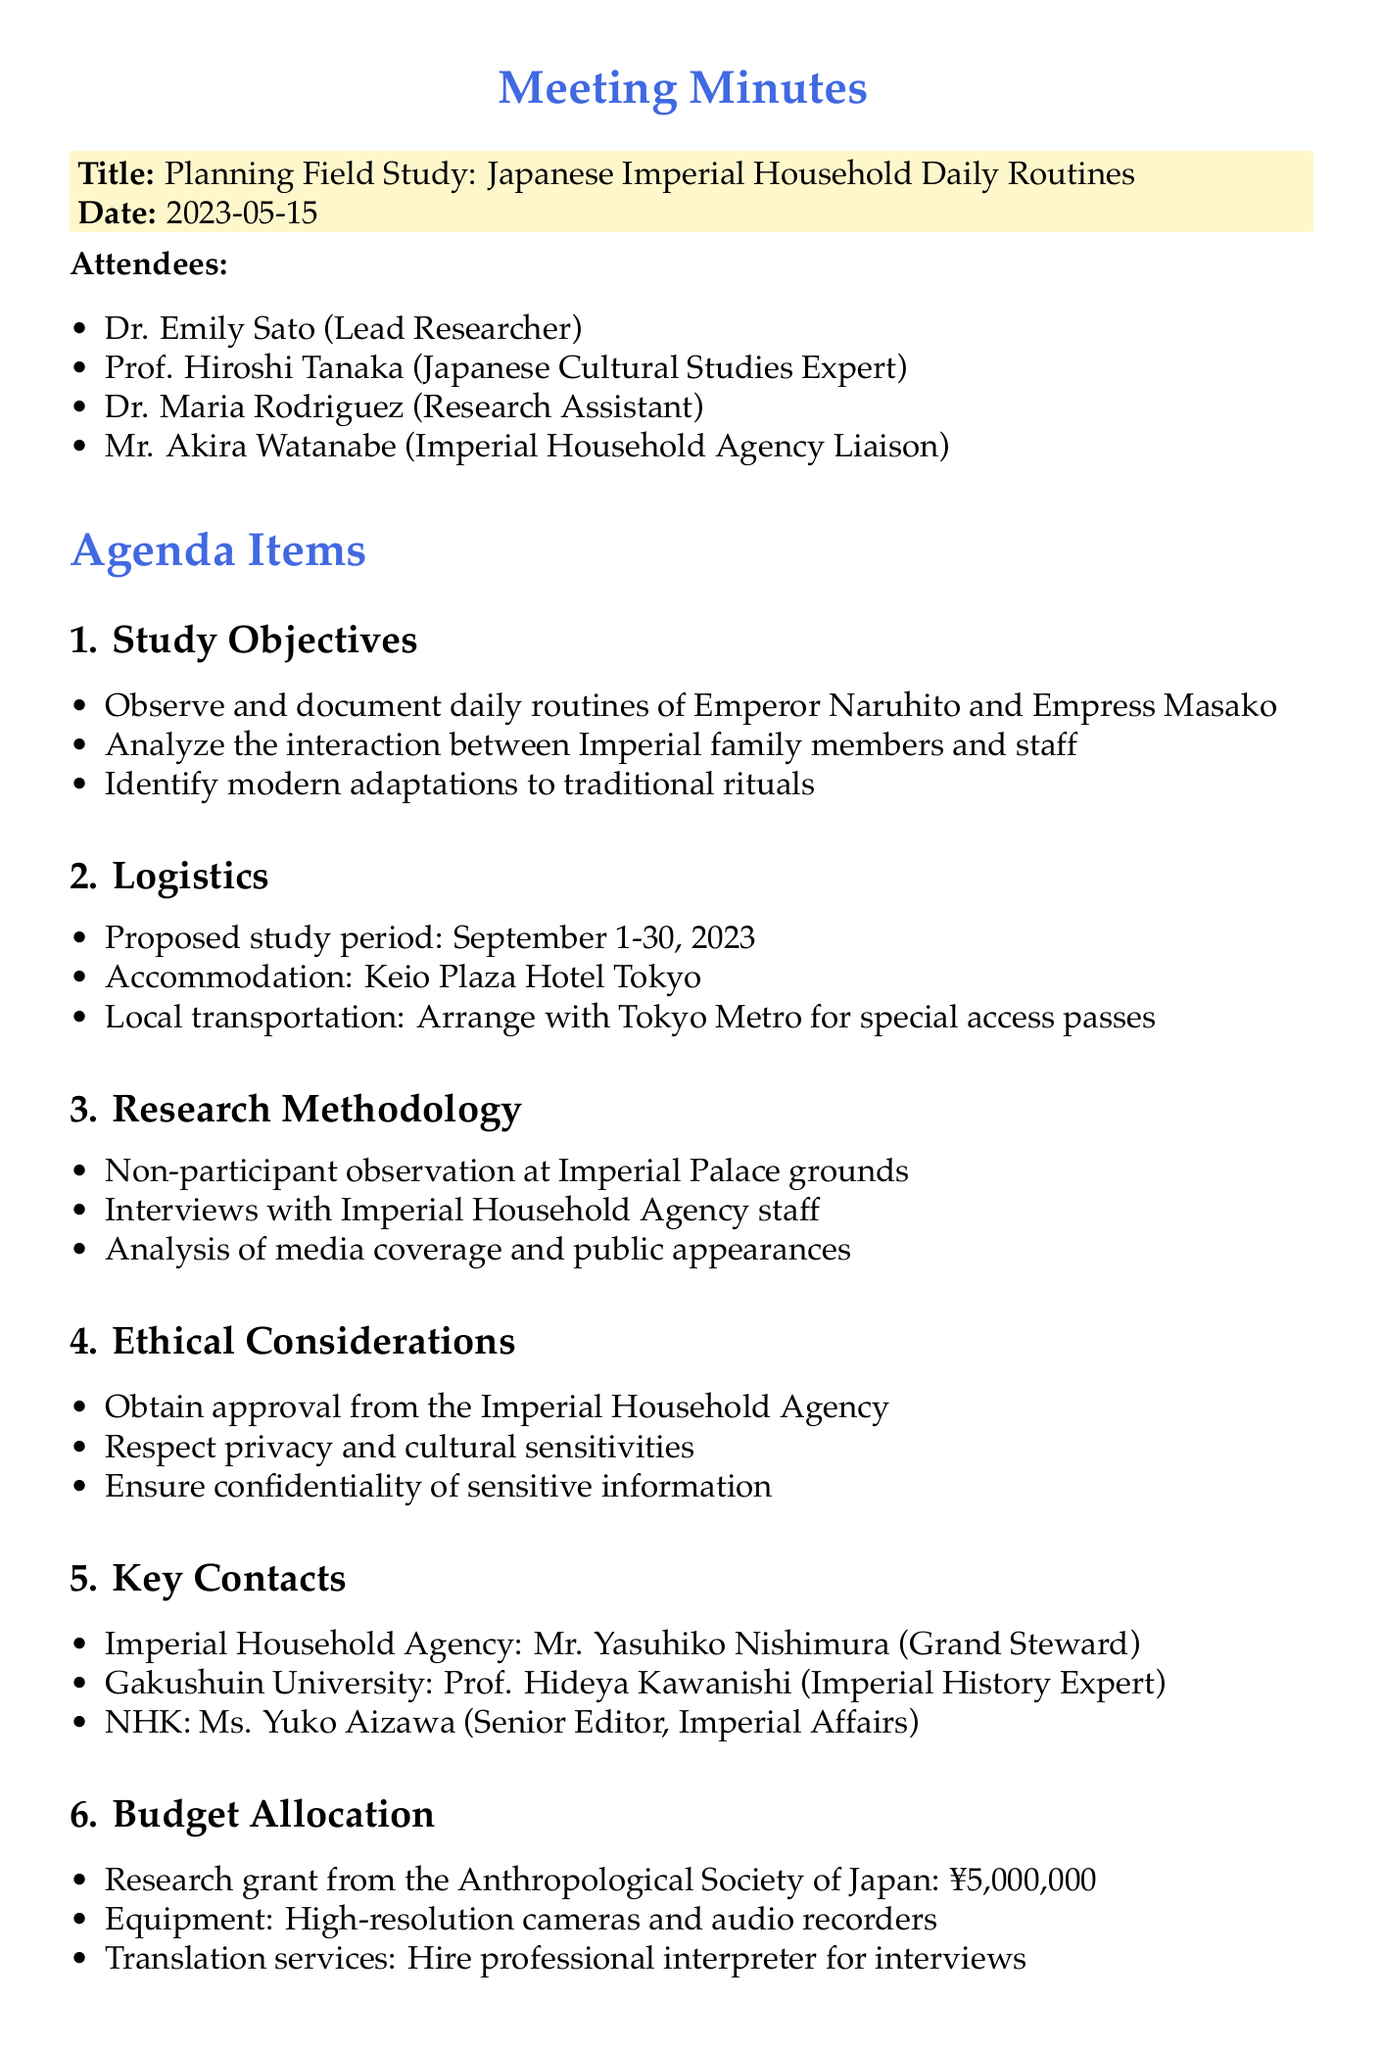what is the title of the meeting? The title of the meeting is explicitly stated in the document under the title section.
Answer: Planning Field Study: Japanese Imperial Household Daily Routines who is the lead researcher? The document lists Dr. Emily Sato as the lead researcher among the attendees.
Answer: Dr. Emily Sato when is the proposed study period? The proposed study period is mentioned clearly under the logistics agenda item.
Answer: September 1-30, 2023 what is the budget from the Anthropological Society of Japan? The budget allocation section specifies the amount received from the grant.
Answer: ¥5,000,000 who will prepare the interview questionnaires? The action items specify that Dr. Rodriguez is responsible for preparing the interview questionnaires.
Answer: Dr. Rodriguez what type of research methodology will be used? The document outlines various methods in the research methodology section, including a form of observation.
Answer: Non-participant observation who is the Grand Steward of the Imperial Household Agency? The key contacts section includes the name and title of the person serving in that role.
Answer: Mr. Yasuhiko Nishimura what ethical consideration is mentioned in the document? The ethical considerations section lists multiple aspects, one of which addresses respect.
Answer: Respect privacy and cultural sensitivities 